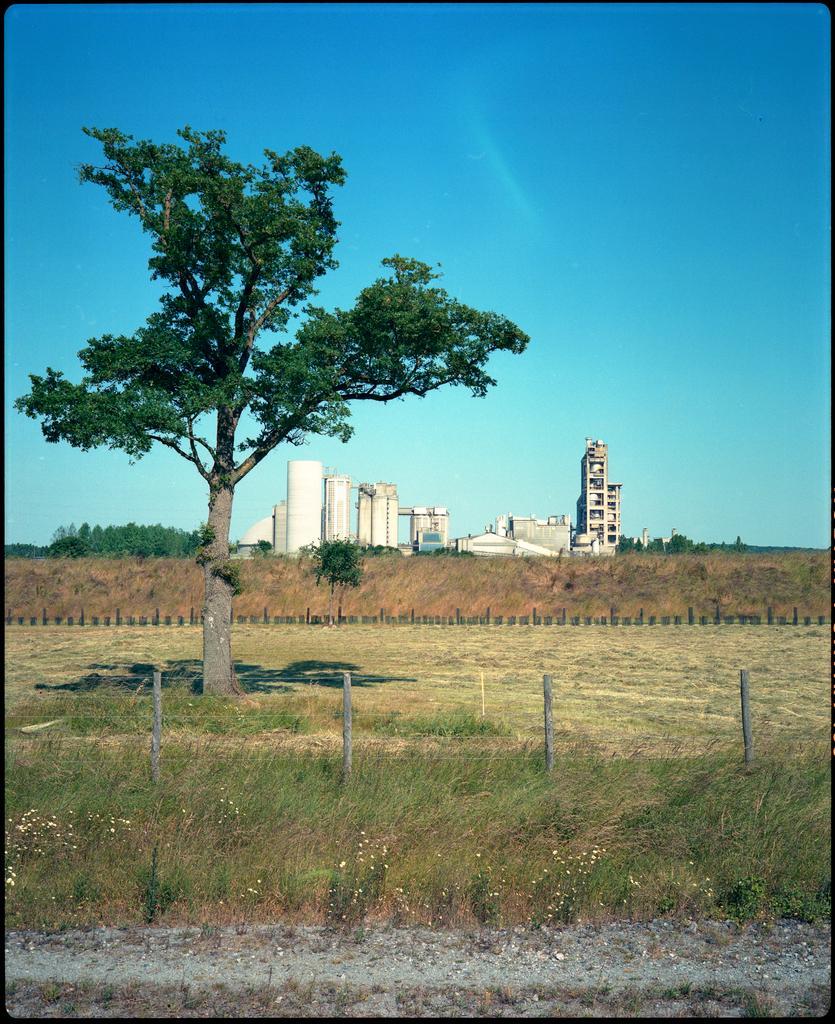Could you give a brief overview of what you see in this image? In this image we can see some buildings, one fence with poles, some plants with flowers, some poles, one road, some trees, bushes, plants and grass on the ground. At the top there is the sky. 